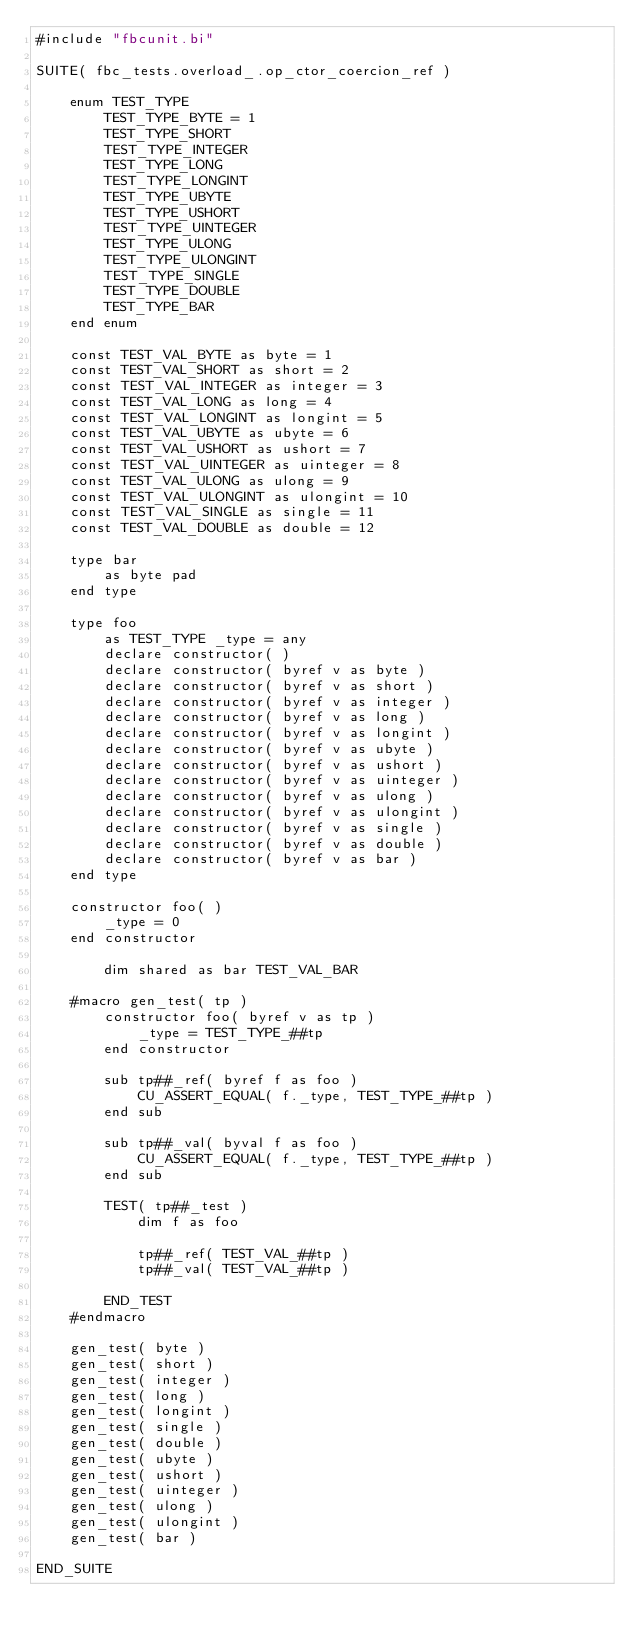<code> <loc_0><loc_0><loc_500><loc_500><_VisualBasic_>#include "fbcunit.bi"

SUITE( fbc_tests.overload_.op_ctor_coercion_ref )

	enum TEST_TYPE
		TEST_TYPE_BYTE = 1
		TEST_TYPE_SHORT
		TEST_TYPE_INTEGER
		TEST_TYPE_LONG
		TEST_TYPE_LONGINT
		TEST_TYPE_UBYTE
		TEST_TYPE_USHORT
		TEST_TYPE_UINTEGER
		TEST_TYPE_ULONG
		TEST_TYPE_ULONGINT
		TEST_TYPE_SINGLE
		TEST_TYPE_DOUBLE
		TEST_TYPE_BAR
	end enum

	const TEST_VAL_BYTE as byte = 1
	const TEST_VAL_SHORT as short = 2
	const TEST_VAL_INTEGER as integer = 3
	const TEST_VAL_LONG as long = 4
	const TEST_VAL_LONGINT as longint = 5
	const TEST_VAL_UBYTE as ubyte = 6
	const TEST_VAL_USHORT as ushort = 7
	const TEST_VAL_UINTEGER as uinteger = 8
	const TEST_VAL_ULONG as ulong = 9
	const TEST_VAL_ULONGINT as ulongint = 10
	const TEST_VAL_SINGLE as single = 11
	const TEST_VAL_DOUBLE as double = 12
		
	type bar
		as byte pad
	end type

	type foo
		as TEST_TYPE _type = any
		declare constructor( )
		declare constructor( byref v as byte )
		declare constructor( byref v as short )
		declare constructor( byref v as integer )
		declare constructor( byref v as long )
		declare constructor( byref v as longint )
		declare constructor( byref v as ubyte )
		declare constructor( byref v as ushort )
		declare constructor( byref v as uinteger )
		declare constructor( byref v as ulong )
		declare constructor( byref v as ulongint )
		declare constructor( byref v as single )
		declare constructor( byref v as double )
		declare constructor( byref v as bar )
	end type

	constructor foo( )
		_type = 0
	end constructor

		dim shared as bar TEST_VAL_BAR

	#macro gen_test( tp )
		constructor foo( byref v as tp )
			_type = TEST_TYPE_##tp
		end constructor

		sub tp##_ref( byref f as foo )
			CU_ASSERT_EQUAL( f._type, TEST_TYPE_##tp )
		end sub
		
		sub tp##_val( byval f as foo )
			CU_ASSERT_EQUAL( f._type, TEST_TYPE_##tp )
		end sub

		TEST( tp##_test )
			dim f as foo
			
			tp##_ref( TEST_VAL_##tp )
			tp##_val( TEST_VAL_##tp )
			
		END_TEST
	#endmacro

	gen_test( byte )
	gen_test( short )
	gen_test( integer )
	gen_test( long )
	gen_test( longint )
	gen_test( single )
	gen_test( double )
	gen_test( ubyte )
	gen_test( ushort )
	gen_test( uinteger )
	gen_test( ulong )
	gen_test( ulongint )
	gen_test( bar )

END_SUITE
</code> 